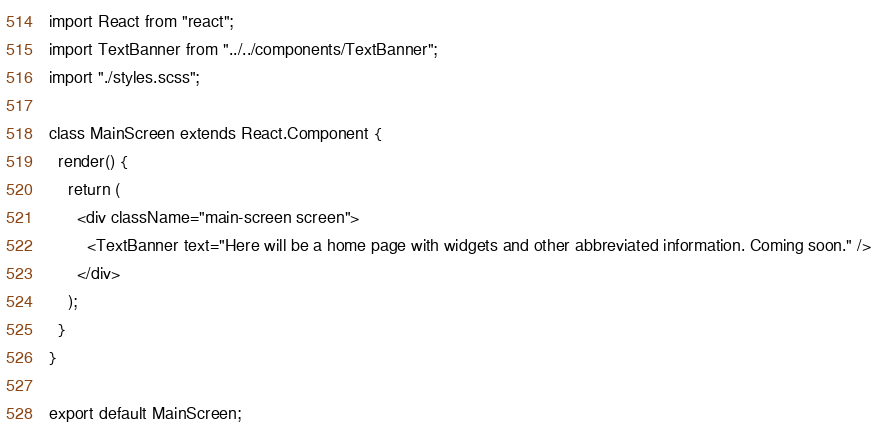Convert code to text. <code><loc_0><loc_0><loc_500><loc_500><_JavaScript_>import React from "react";
import TextBanner from "../../components/TextBanner";
import "./styles.scss";

class MainScreen extends React.Component {
  render() {
    return (
      <div className="main-screen screen">
        <TextBanner text="Here will be a home page with widgets and other abbreviated information. Coming soon." />
      </div>
    );
  }
}

export default MainScreen;
</code> 